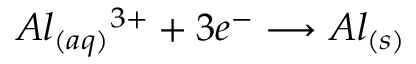<formula> <loc_0><loc_0><loc_500><loc_500>A l _ { ( a q ) } { ^ { 3 + } } + 3 e ^ { - } \longrightarrow A l _ { ( s ) }</formula> 